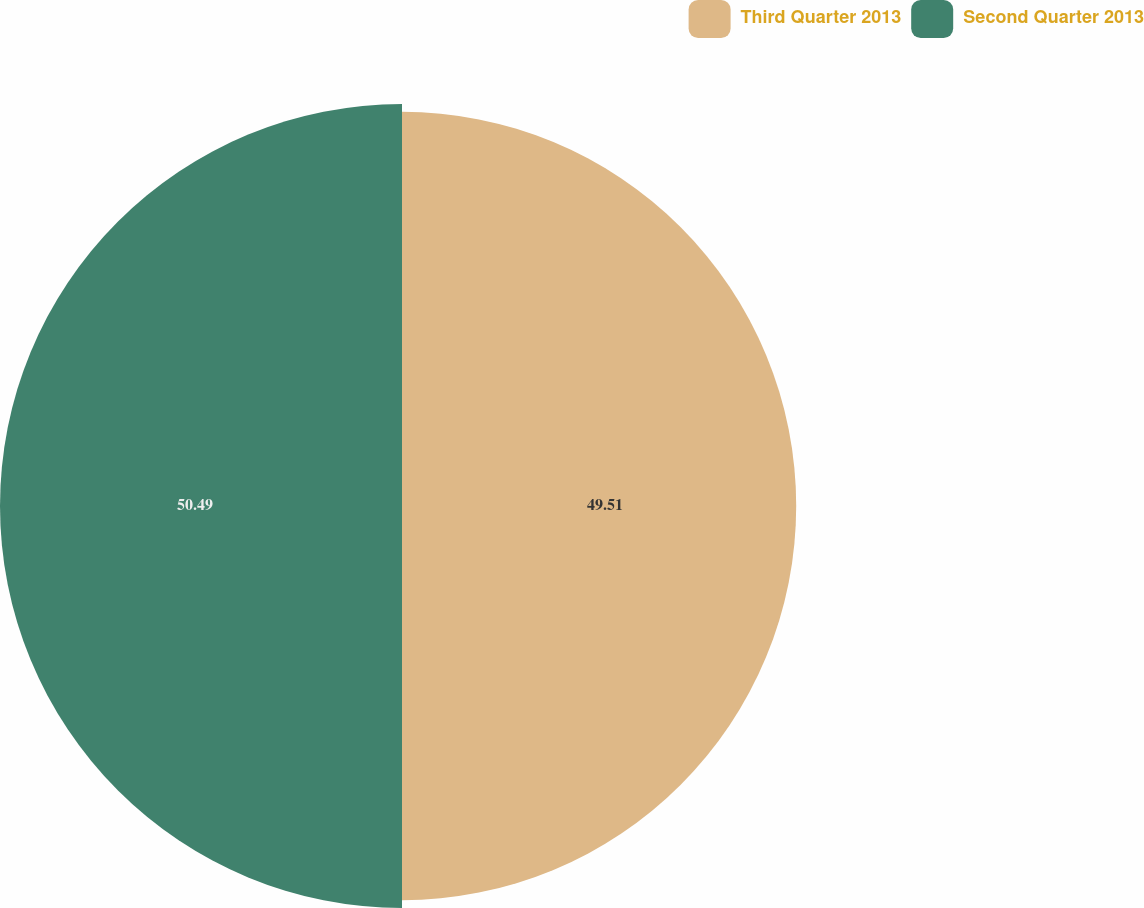<chart> <loc_0><loc_0><loc_500><loc_500><pie_chart><fcel>Third Quarter 2013<fcel>Second Quarter 2013<nl><fcel>49.51%<fcel>50.49%<nl></chart> 